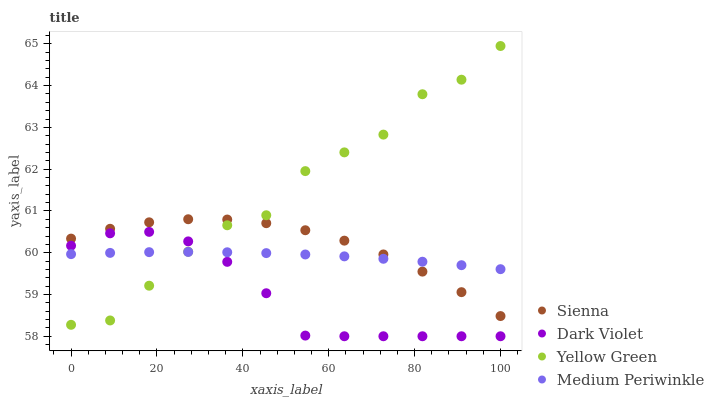Does Dark Violet have the minimum area under the curve?
Answer yes or no. Yes. Does Yellow Green have the maximum area under the curve?
Answer yes or no. Yes. Does Medium Periwinkle have the minimum area under the curve?
Answer yes or no. No. Does Medium Periwinkle have the maximum area under the curve?
Answer yes or no. No. Is Medium Periwinkle the smoothest?
Answer yes or no. Yes. Is Yellow Green the roughest?
Answer yes or no. Yes. Is Yellow Green the smoothest?
Answer yes or no. No. Is Medium Periwinkle the roughest?
Answer yes or no. No. Does Dark Violet have the lowest value?
Answer yes or no. Yes. Does Yellow Green have the lowest value?
Answer yes or no. No. Does Yellow Green have the highest value?
Answer yes or no. Yes. Does Medium Periwinkle have the highest value?
Answer yes or no. No. Is Dark Violet less than Sienna?
Answer yes or no. Yes. Is Sienna greater than Dark Violet?
Answer yes or no. Yes. Does Yellow Green intersect Medium Periwinkle?
Answer yes or no. Yes. Is Yellow Green less than Medium Periwinkle?
Answer yes or no. No. Is Yellow Green greater than Medium Periwinkle?
Answer yes or no. No. Does Dark Violet intersect Sienna?
Answer yes or no. No. 